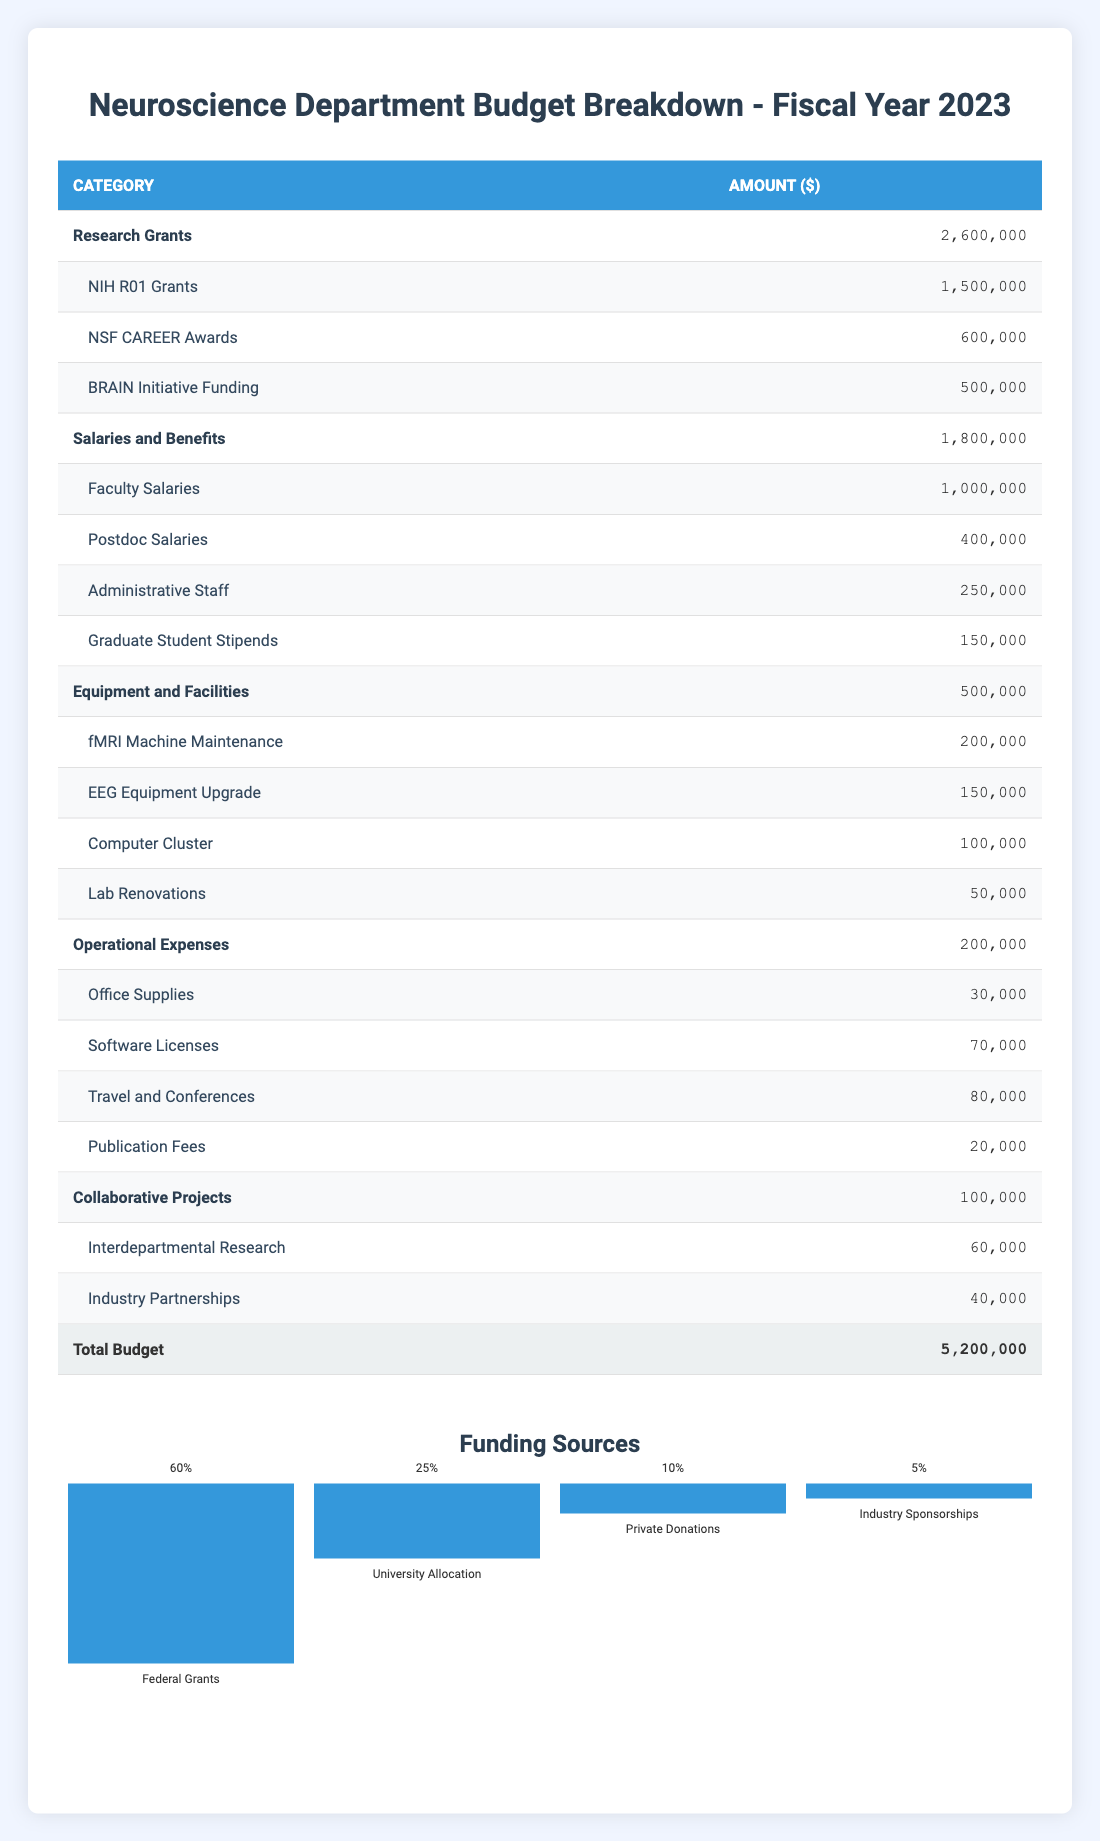What is the total budget for the Neuroscience Department in fiscal year 2023? The total budget is specifically stated in the last row of the table, which lists a total budget amount of 5,200,000.
Answer: 5,200,000 How much is allocated to Research Grants? The table lists Research Grants as a category with an allocated amount of 2,600,000.
Answer: 2,600,000 What percentage of the total budget is spent on Salaries and Benefits? Salaries and Benefits have an allocated amount of 1,800,000, and the total budget is 5,200,000. To find the percentage, we calculate (1,800,000 / 5,200,000) * 100 = 34.62%.
Answer: 34.62% True or False: The amount spent on Equipment and Facilities is greater than the amount spent on Operational Expenses. Equipment and Facilities has an amount of 500,000, while Operational Expenses is 200,000. Since 500,000 is greater than 200,000, the statement is true.
Answer: True What is the sum of the funding from Federal Grants and University Allocation? Federal Grants contribute 60% to the budget while University Allocation contributes 25%. To find the actual amounts, we multiply the total budget 5,200,000 by each percentage: 5,200,000 * 0.60 = 3,120,000 for Federal Grants, and 5,200,000 * 0.25 = 1,300,000 for University Allocation. The sum is 3,120,000 + 1,300,000 = 4,420,000.
Answer: 4,420,000 How much more is allocated to NIH R01 Grants compared to Graduate Student Stipends? The NIH R01 Grants amount to 1,500,000 and Graduate Student Stipends to 150,000. To find the difference, we subtract 150,000 from 1,500,000, which gives 1,350,000.
Answer: 1,350,000 What proportion of the total budget is represented by Collaborative Projects? Collaborative Projects have a budget allocation of 100,000. To find the proportion, we calculate (100,000 / 5,200,000) * 100 = 1.92%.
Answer: 1.92% Which category has the least amount allocated to it in the budget? By comparing all category amounts listed, Collaborative Projects has the least allocation of 100,000.
Answer: Collaborative Projects What is the total amount allocated to the subcategories within Equipment and Facilities? To find this, we add the amounts of all subcategories under Equipment and Facilities: 200,000 (fMRI Machine Maintenance) + 150,000 (EEG Equipment Upgrade) + 100,000 (Computer Cluster) + 50,000 (Lab Renovations) = 500,000. The total matches the Equipment and Facilities amount.
Answer: 500,000 